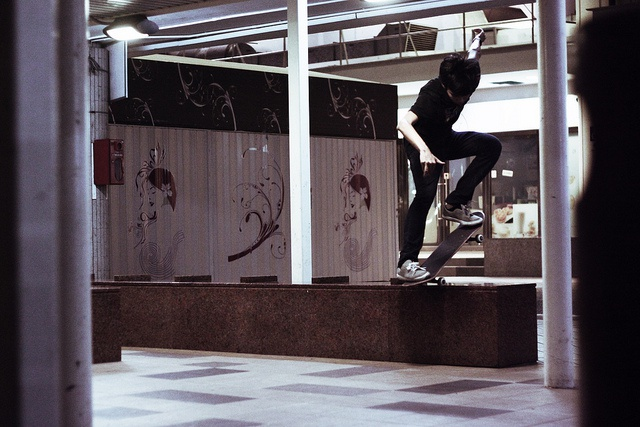Describe the objects in this image and their specific colors. I can see people in black, white, gray, and darkgray tones and skateboard in black, gray, and darkgray tones in this image. 